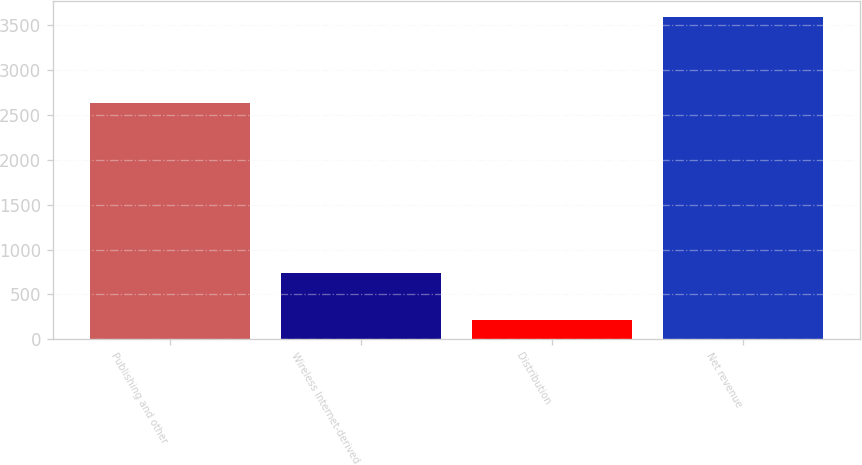Convert chart. <chart><loc_0><loc_0><loc_500><loc_500><bar_chart><fcel>Publishing and other<fcel>Wireless Internet-derived<fcel>Distribution<fcel>Net revenue<nl><fcel>2632<fcel>743<fcel>214<fcel>3589<nl></chart> 